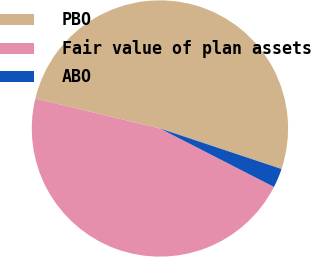Convert chart. <chart><loc_0><loc_0><loc_500><loc_500><pie_chart><fcel>PBO<fcel>Fair value of plan assets<fcel>ABO<nl><fcel>51.36%<fcel>46.21%<fcel>2.42%<nl></chart> 